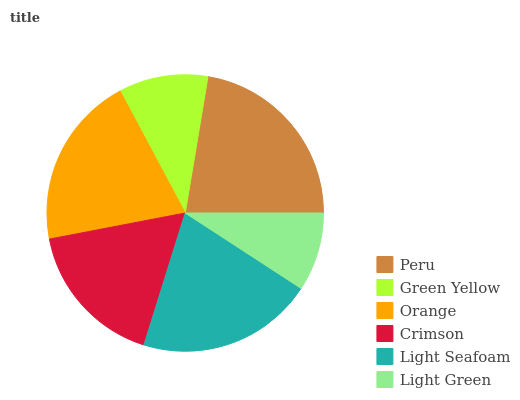Is Light Green the minimum?
Answer yes or no. Yes. Is Peru the maximum?
Answer yes or no. Yes. Is Green Yellow the minimum?
Answer yes or no. No. Is Green Yellow the maximum?
Answer yes or no. No. Is Peru greater than Green Yellow?
Answer yes or no. Yes. Is Green Yellow less than Peru?
Answer yes or no. Yes. Is Green Yellow greater than Peru?
Answer yes or no. No. Is Peru less than Green Yellow?
Answer yes or no. No. Is Orange the high median?
Answer yes or no. Yes. Is Crimson the low median?
Answer yes or no. Yes. Is Green Yellow the high median?
Answer yes or no. No. Is Light Green the low median?
Answer yes or no. No. 